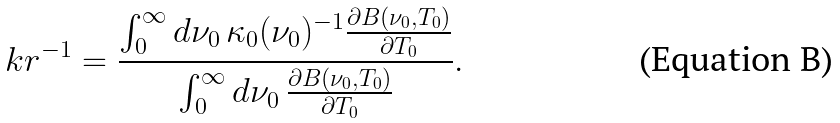Convert formula to latex. <formula><loc_0><loc_0><loc_500><loc_500>\ k r ^ { - 1 } = \frac { \int _ { 0 } ^ { \infty } d \nu _ { 0 } \, \kappa _ { 0 } ( \nu _ { 0 } ) ^ { - 1 } \frac { \partial B ( \nu _ { 0 } , T _ { 0 } ) } { \partial T _ { 0 } } } { \int _ { 0 } ^ { \infty } d \nu _ { 0 } \, \frac { \partial B ( \nu _ { 0 } , T _ { 0 } ) } { \partial T _ { 0 } } } .</formula> 